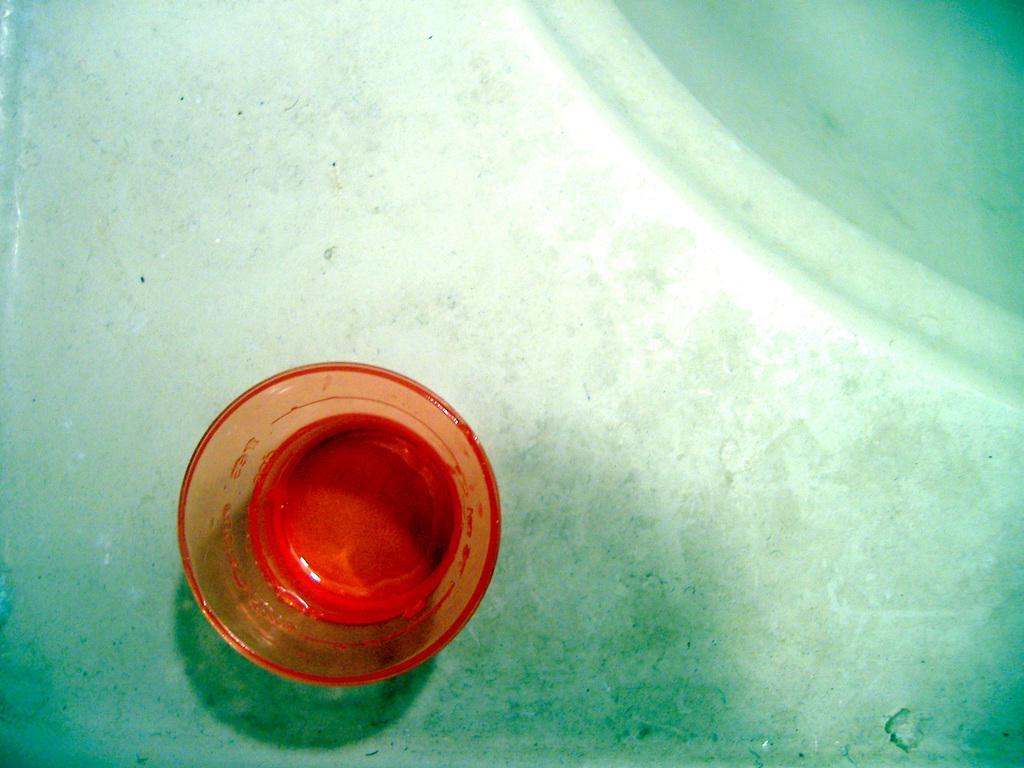In one or two sentences, can you explain what this image depicts? In this image, we can see a glass object on the surface. 